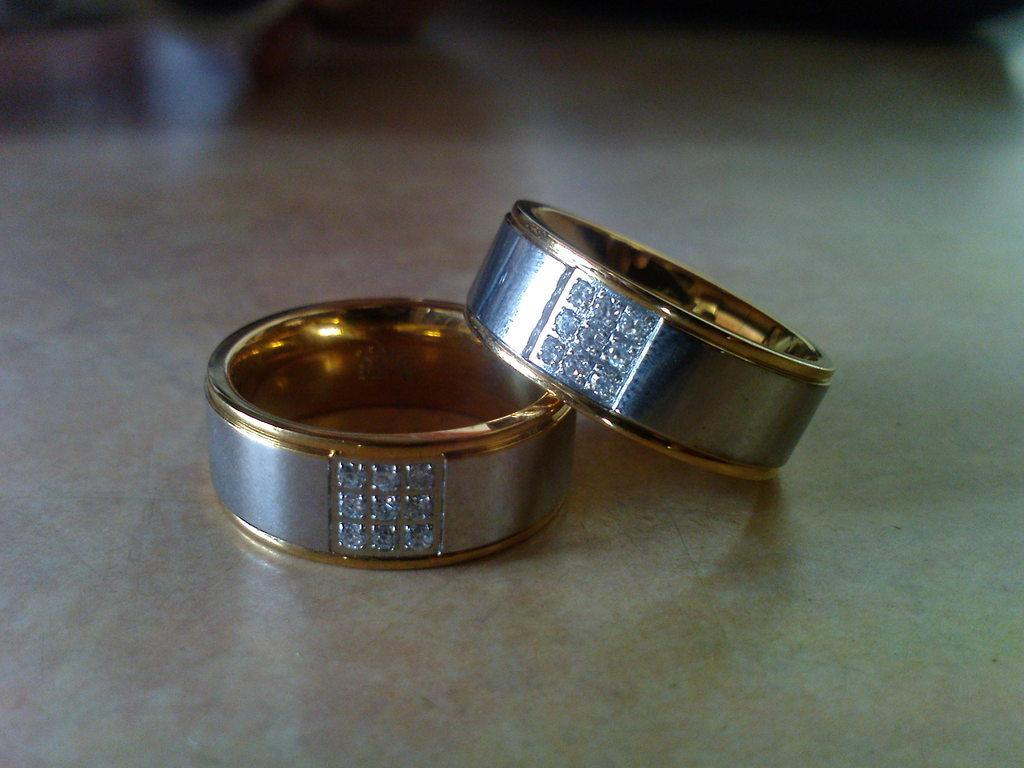What objects are on the floor in the image? There are two hand rings on the floor in the image. Can you describe the position of the hand rings? The hand rings are on the floor. What type of sound can be heard coming from the hand rings in the image? There is no sound coming from the hand rings in the image, as they are inanimate objects. 